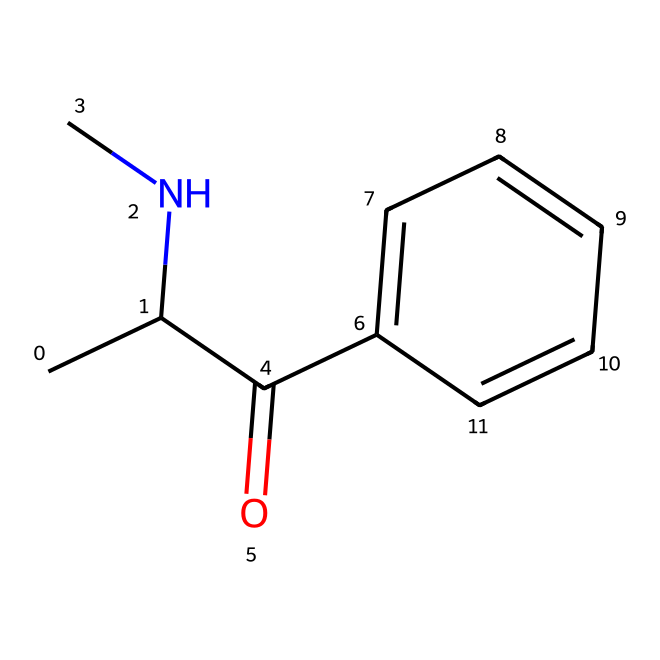What is the molecular formula of khat? The SMILES representation provided can be decoded to count the number of each type of atom in the structure. By analyzing it, we see that there are 11 carbon (C) atoms, 15 hydrogen (H) atoms, 2 nitrogen (N) atoms, and 1 oxygen (O) atom. Therefore, the molecular formula is C11H15N2O.
Answer: C11H15N2O How many rings are present in the structure? When examining the chemical structure represented by the SMILES, there is one aromatic ring indicated by "c1ccccc1," which shows that there is one six-membered carbon ring. Thus, the number of rings is one.
Answer: 1 What type of functional group is present in khat? The structure shows a carbonyl group (C=O) identified from the "C(=O)" part of the SMILES. Since this is an amide, particularly from the presence of the nitrogen and the carbonyl group, it is an amide functional group.
Answer: amide Is there a hypervalent molecule present? To establish if the molecule in the given chemical structure is hypervalent, we need to check if any atom has more than four bonds. In this structure, although the nitrogen atoms form three bonds, no atom has more than four bonds; therefore, this compound can be classified as not hypervalent.
Answer: no Which atom is likely responsible for the stimulant effects of khat? In the structure, the nitrogen atoms can be crucial as they are components of alkaloids, known for their stimulant properties. The presence of these nitrogen atoms suggests that they play a significant role in the stimulant effects.
Answer: nitrogen How many hydrogen atoms are bonded to the nitrogen atoms? In the structural analysis, we observe that each nitrogen in the amide typically bonds to one hydrogen atom. Therefore, because there are two nitrogen atoms, the total is two hydrogen atoms attached to nitrogen.
Answer: 2 